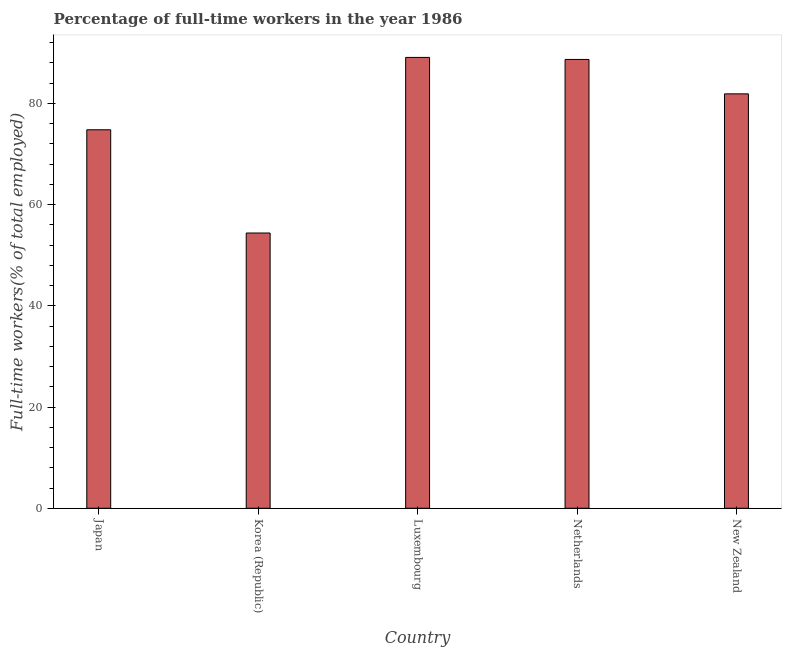Does the graph contain any zero values?
Your answer should be compact. No. Does the graph contain grids?
Offer a very short reply. No. What is the title of the graph?
Give a very brief answer. Percentage of full-time workers in the year 1986. What is the label or title of the X-axis?
Your response must be concise. Country. What is the label or title of the Y-axis?
Your answer should be very brief. Full-time workers(% of total employed). What is the percentage of full-time workers in Netherlands?
Offer a terse response. 88.7. Across all countries, what is the maximum percentage of full-time workers?
Ensure brevity in your answer.  89.1. Across all countries, what is the minimum percentage of full-time workers?
Provide a succinct answer. 54.4. In which country was the percentage of full-time workers maximum?
Provide a succinct answer. Luxembourg. What is the sum of the percentage of full-time workers?
Offer a terse response. 388.9. What is the difference between the percentage of full-time workers in Korea (Republic) and Luxembourg?
Give a very brief answer. -34.7. What is the average percentage of full-time workers per country?
Give a very brief answer. 77.78. What is the median percentage of full-time workers?
Offer a terse response. 81.9. What is the ratio of the percentage of full-time workers in Japan to that in Netherlands?
Give a very brief answer. 0.84. Is the percentage of full-time workers in Japan less than that in Luxembourg?
Provide a succinct answer. Yes. What is the difference between the highest and the second highest percentage of full-time workers?
Your response must be concise. 0.4. What is the difference between the highest and the lowest percentage of full-time workers?
Your response must be concise. 34.7. In how many countries, is the percentage of full-time workers greater than the average percentage of full-time workers taken over all countries?
Ensure brevity in your answer.  3. Are all the bars in the graph horizontal?
Offer a terse response. No. What is the Full-time workers(% of total employed) of Japan?
Provide a short and direct response. 74.8. What is the Full-time workers(% of total employed) of Korea (Republic)?
Provide a short and direct response. 54.4. What is the Full-time workers(% of total employed) in Luxembourg?
Ensure brevity in your answer.  89.1. What is the Full-time workers(% of total employed) of Netherlands?
Your answer should be compact. 88.7. What is the Full-time workers(% of total employed) of New Zealand?
Give a very brief answer. 81.9. What is the difference between the Full-time workers(% of total employed) in Japan and Korea (Republic)?
Provide a succinct answer. 20.4. What is the difference between the Full-time workers(% of total employed) in Japan and Luxembourg?
Make the answer very short. -14.3. What is the difference between the Full-time workers(% of total employed) in Japan and Netherlands?
Provide a short and direct response. -13.9. What is the difference between the Full-time workers(% of total employed) in Japan and New Zealand?
Provide a short and direct response. -7.1. What is the difference between the Full-time workers(% of total employed) in Korea (Republic) and Luxembourg?
Your answer should be very brief. -34.7. What is the difference between the Full-time workers(% of total employed) in Korea (Republic) and Netherlands?
Provide a succinct answer. -34.3. What is the difference between the Full-time workers(% of total employed) in Korea (Republic) and New Zealand?
Offer a terse response. -27.5. What is the difference between the Full-time workers(% of total employed) in Luxembourg and New Zealand?
Ensure brevity in your answer.  7.2. What is the ratio of the Full-time workers(% of total employed) in Japan to that in Korea (Republic)?
Your answer should be very brief. 1.38. What is the ratio of the Full-time workers(% of total employed) in Japan to that in Luxembourg?
Ensure brevity in your answer.  0.84. What is the ratio of the Full-time workers(% of total employed) in Japan to that in Netherlands?
Offer a very short reply. 0.84. What is the ratio of the Full-time workers(% of total employed) in Japan to that in New Zealand?
Your answer should be very brief. 0.91. What is the ratio of the Full-time workers(% of total employed) in Korea (Republic) to that in Luxembourg?
Make the answer very short. 0.61. What is the ratio of the Full-time workers(% of total employed) in Korea (Republic) to that in Netherlands?
Your response must be concise. 0.61. What is the ratio of the Full-time workers(% of total employed) in Korea (Republic) to that in New Zealand?
Give a very brief answer. 0.66. What is the ratio of the Full-time workers(% of total employed) in Luxembourg to that in New Zealand?
Offer a terse response. 1.09. What is the ratio of the Full-time workers(% of total employed) in Netherlands to that in New Zealand?
Offer a very short reply. 1.08. 